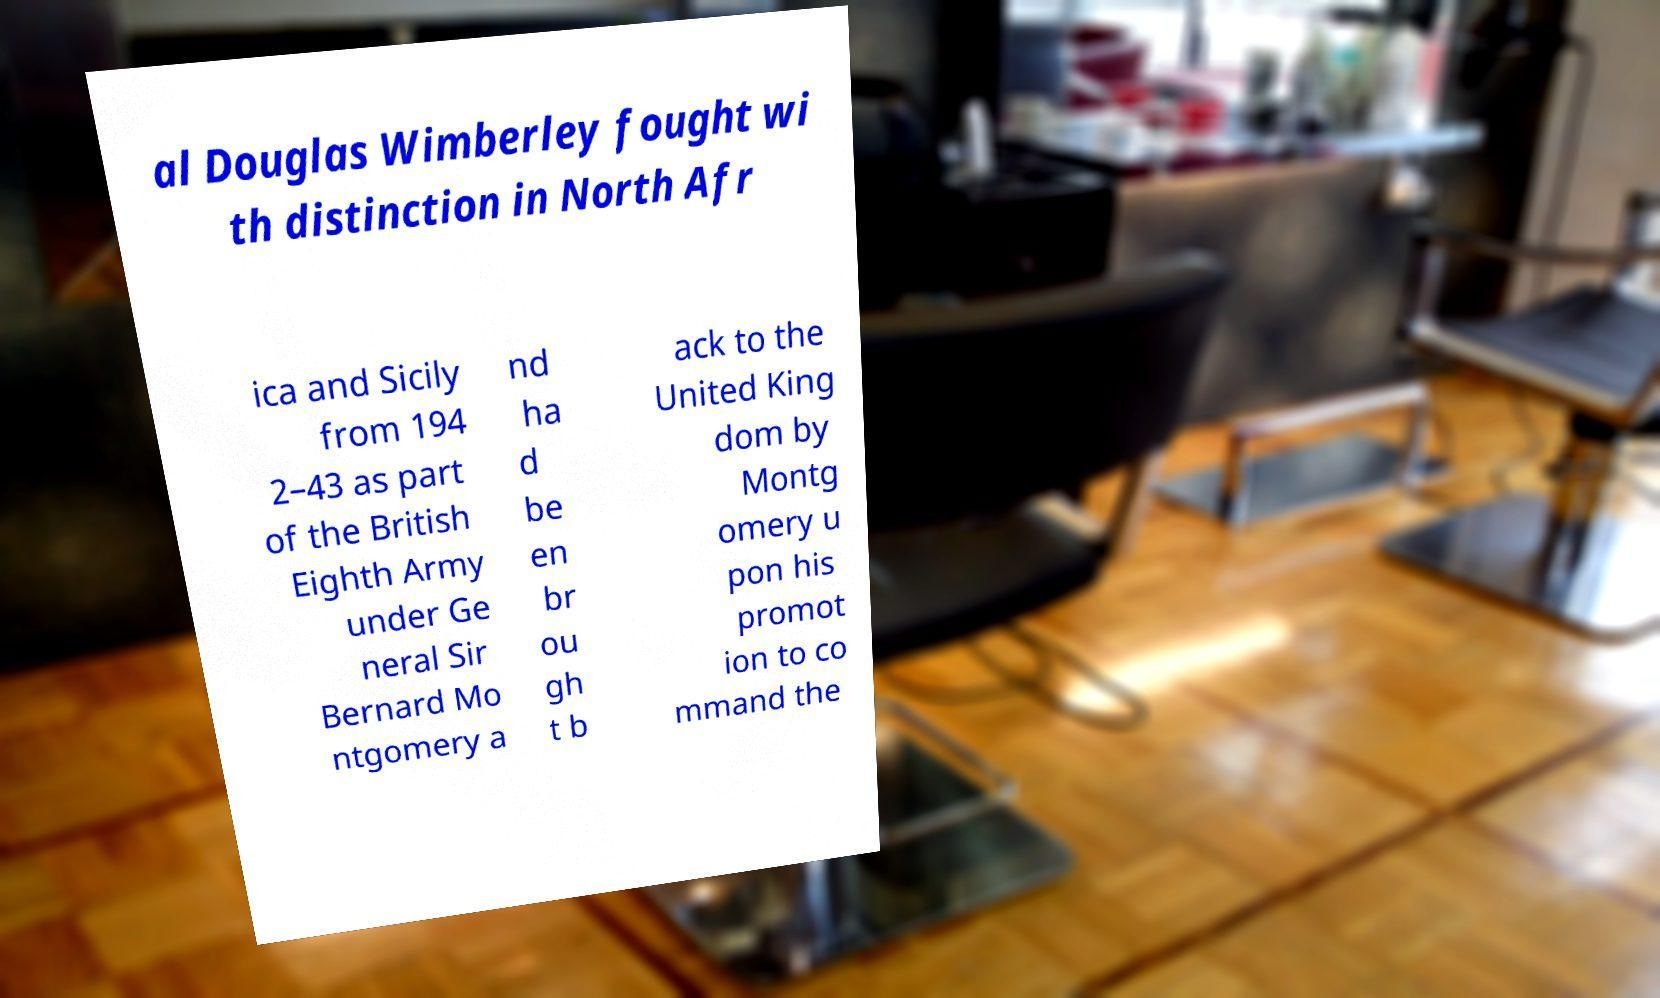Can you accurately transcribe the text from the provided image for me? al Douglas Wimberley fought wi th distinction in North Afr ica and Sicily from 194 2–43 as part of the British Eighth Army under Ge neral Sir Bernard Mo ntgomery a nd ha d be en br ou gh t b ack to the United King dom by Montg omery u pon his promot ion to co mmand the 